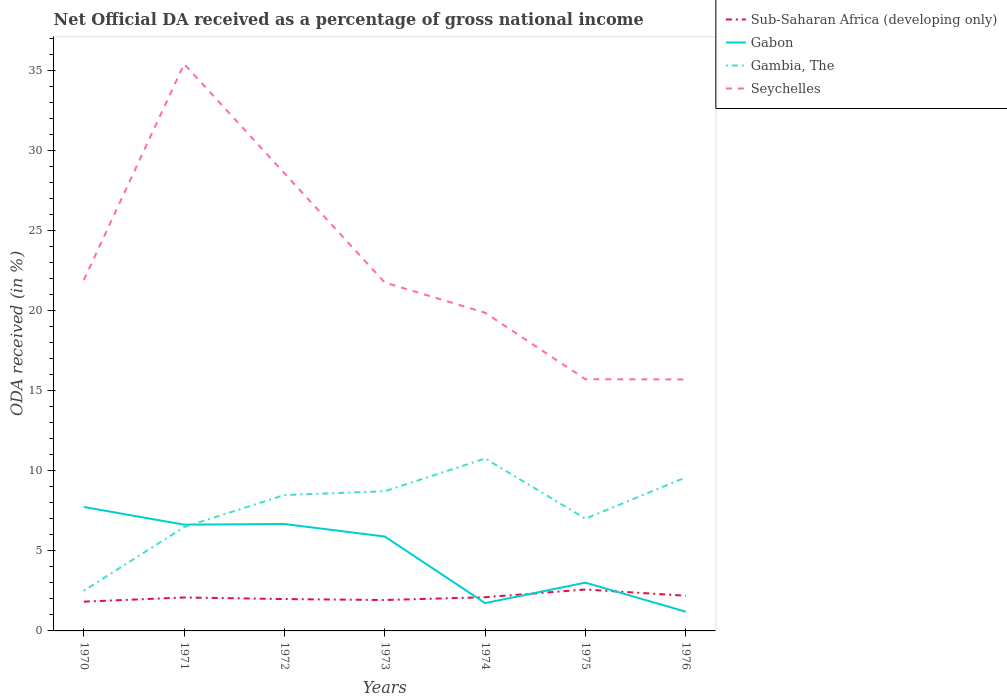How many different coloured lines are there?
Your answer should be very brief. 4. Across all years, what is the maximum net official DA received in Gabon?
Offer a terse response. 1.2. In which year was the net official DA received in Seychelles maximum?
Offer a terse response. 1976. What is the total net official DA received in Gambia, The in the graph?
Give a very brief answer. -0.24. What is the difference between the highest and the second highest net official DA received in Gambia, The?
Provide a short and direct response. 8.26. What is the difference between the highest and the lowest net official DA received in Seychelles?
Offer a terse response. 2. How many lines are there?
Offer a very short reply. 4. How are the legend labels stacked?
Give a very brief answer. Vertical. What is the title of the graph?
Your answer should be very brief. Net Official DA received as a percentage of gross national income. What is the label or title of the Y-axis?
Provide a succinct answer. ODA received (in %). What is the ODA received (in %) of Sub-Saharan Africa (developing only) in 1970?
Your response must be concise. 1.83. What is the ODA received (in %) in Gabon in 1970?
Give a very brief answer. 7.74. What is the ODA received (in %) in Gambia, The in 1970?
Keep it short and to the point. 2.5. What is the ODA received (in %) in Seychelles in 1970?
Keep it short and to the point. 21.9. What is the ODA received (in %) of Sub-Saharan Africa (developing only) in 1971?
Give a very brief answer. 2.09. What is the ODA received (in %) of Gabon in 1971?
Offer a terse response. 6.63. What is the ODA received (in %) of Gambia, The in 1971?
Your answer should be compact. 6.48. What is the ODA received (in %) in Seychelles in 1971?
Ensure brevity in your answer.  35.38. What is the ODA received (in %) in Sub-Saharan Africa (developing only) in 1972?
Provide a short and direct response. 1.99. What is the ODA received (in %) of Gabon in 1972?
Your answer should be compact. 6.67. What is the ODA received (in %) in Gambia, The in 1972?
Give a very brief answer. 8.48. What is the ODA received (in %) of Seychelles in 1972?
Your response must be concise. 28.56. What is the ODA received (in %) of Sub-Saharan Africa (developing only) in 1973?
Your response must be concise. 1.93. What is the ODA received (in %) of Gabon in 1973?
Provide a short and direct response. 5.89. What is the ODA received (in %) of Gambia, The in 1973?
Make the answer very short. 8.72. What is the ODA received (in %) of Seychelles in 1973?
Provide a succinct answer. 21.74. What is the ODA received (in %) of Sub-Saharan Africa (developing only) in 1974?
Offer a terse response. 2.1. What is the ODA received (in %) in Gabon in 1974?
Make the answer very short. 1.74. What is the ODA received (in %) of Gambia, The in 1974?
Keep it short and to the point. 10.76. What is the ODA received (in %) of Seychelles in 1974?
Your answer should be compact. 19.86. What is the ODA received (in %) in Sub-Saharan Africa (developing only) in 1975?
Offer a very short reply. 2.58. What is the ODA received (in %) in Gabon in 1975?
Offer a terse response. 3.01. What is the ODA received (in %) in Gambia, The in 1975?
Offer a very short reply. 7.01. What is the ODA received (in %) of Seychelles in 1975?
Offer a very short reply. 15.71. What is the ODA received (in %) in Sub-Saharan Africa (developing only) in 1976?
Keep it short and to the point. 2.2. What is the ODA received (in %) in Gabon in 1976?
Make the answer very short. 1.2. What is the ODA received (in %) in Gambia, The in 1976?
Keep it short and to the point. 9.58. What is the ODA received (in %) in Seychelles in 1976?
Offer a very short reply. 15.69. Across all years, what is the maximum ODA received (in %) in Sub-Saharan Africa (developing only)?
Ensure brevity in your answer.  2.58. Across all years, what is the maximum ODA received (in %) of Gabon?
Ensure brevity in your answer.  7.74. Across all years, what is the maximum ODA received (in %) in Gambia, The?
Your response must be concise. 10.76. Across all years, what is the maximum ODA received (in %) in Seychelles?
Offer a terse response. 35.38. Across all years, what is the minimum ODA received (in %) of Sub-Saharan Africa (developing only)?
Ensure brevity in your answer.  1.83. Across all years, what is the minimum ODA received (in %) in Gabon?
Offer a terse response. 1.2. Across all years, what is the minimum ODA received (in %) of Gambia, The?
Offer a terse response. 2.5. Across all years, what is the minimum ODA received (in %) of Seychelles?
Your answer should be compact. 15.69. What is the total ODA received (in %) in Sub-Saharan Africa (developing only) in the graph?
Provide a succinct answer. 14.71. What is the total ODA received (in %) in Gabon in the graph?
Keep it short and to the point. 32.88. What is the total ODA received (in %) in Gambia, The in the graph?
Your answer should be compact. 53.53. What is the total ODA received (in %) in Seychelles in the graph?
Your response must be concise. 158.84. What is the difference between the ODA received (in %) in Sub-Saharan Africa (developing only) in 1970 and that in 1971?
Ensure brevity in your answer.  -0.26. What is the difference between the ODA received (in %) in Gabon in 1970 and that in 1971?
Offer a terse response. 1.1. What is the difference between the ODA received (in %) of Gambia, The in 1970 and that in 1971?
Your response must be concise. -3.98. What is the difference between the ODA received (in %) in Seychelles in 1970 and that in 1971?
Your answer should be compact. -13.49. What is the difference between the ODA received (in %) in Sub-Saharan Africa (developing only) in 1970 and that in 1972?
Provide a succinct answer. -0.16. What is the difference between the ODA received (in %) in Gabon in 1970 and that in 1972?
Make the answer very short. 1.06. What is the difference between the ODA received (in %) of Gambia, The in 1970 and that in 1972?
Your answer should be compact. -5.98. What is the difference between the ODA received (in %) in Seychelles in 1970 and that in 1972?
Offer a terse response. -6.66. What is the difference between the ODA received (in %) of Sub-Saharan Africa (developing only) in 1970 and that in 1973?
Offer a very short reply. -0.1. What is the difference between the ODA received (in %) in Gabon in 1970 and that in 1973?
Your answer should be very brief. 1.85. What is the difference between the ODA received (in %) of Gambia, The in 1970 and that in 1973?
Provide a short and direct response. -6.21. What is the difference between the ODA received (in %) of Seychelles in 1970 and that in 1973?
Provide a succinct answer. 0.15. What is the difference between the ODA received (in %) in Sub-Saharan Africa (developing only) in 1970 and that in 1974?
Ensure brevity in your answer.  -0.28. What is the difference between the ODA received (in %) in Gabon in 1970 and that in 1974?
Give a very brief answer. 6. What is the difference between the ODA received (in %) in Gambia, The in 1970 and that in 1974?
Provide a short and direct response. -8.26. What is the difference between the ODA received (in %) of Seychelles in 1970 and that in 1974?
Provide a short and direct response. 2.04. What is the difference between the ODA received (in %) of Sub-Saharan Africa (developing only) in 1970 and that in 1975?
Offer a terse response. -0.76. What is the difference between the ODA received (in %) of Gabon in 1970 and that in 1975?
Provide a succinct answer. 4.72. What is the difference between the ODA received (in %) in Gambia, The in 1970 and that in 1975?
Offer a terse response. -4.5. What is the difference between the ODA received (in %) of Seychelles in 1970 and that in 1975?
Ensure brevity in your answer.  6.19. What is the difference between the ODA received (in %) in Sub-Saharan Africa (developing only) in 1970 and that in 1976?
Your answer should be compact. -0.37. What is the difference between the ODA received (in %) of Gabon in 1970 and that in 1976?
Offer a terse response. 6.54. What is the difference between the ODA received (in %) of Gambia, The in 1970 and that in 1976?
Provide a succinct answer. -7.07. What is the difference between the ODA received (in %) of Seychelles in 1970 and that in 1976?
Your answer should be compact. 6.2. What is the difference between the ODA received (in %) in Sub-Saharan Africa (developing only) in 1971 and that in 1972?
Offer a terse response. 0.1. What is the difference between the ODA received (in %) of Gabon in 1971 and that in 1972?
Keep it short and to the point. -0.04. What is the difference between the ODA received (in %) in Gambia, The in 1971 and that in 1972?
Offer a very short reply. -2. What is the difference between the ODA received (in %) of Seychelles in 1971 and that in 1972?
Give a very brief answer. 6.82. What is the difference between the ODA received (in %) of Sub-Saharan Africa (developing only) in 1971 and that in 1973?
Ensure brevity in your answer.  0.16. What is the difference between the ODA received (in %) in Gabon in 1971 and that in 1973?
Make the answer very short. 0.74. What is the difference between the ODA received (in %) of Gambia, The in 1971 and that in 1973?
Your answer should be compact. -2.23. What is the difference between the ODA received (in %) of Seychelles in 1971 and that in 1973?
Keep it short and to the point. 13.64. What is the difference between the ODA received (in %) of Sub-Saharan Africa (developing only) in 1971 and that in 1974?
Offer a terse response. -0.02. What is the difference between the ODA received (in %) of Gabon in 1971 and that in 1974?
Make the answer very short. 4.89. What is the difference between the ODA received (in %) in Gambia, The in 1971 and that in 1974?
Give a very brief answer. -4.28. What is the difference between the ODA received (in %) of Seychelles in 1971 and that in 1974?
Ensure brevity in your answer.  15.53. What is the difference between the ODA received (in %) in Sub-Saharan Africa (developing only) in 1971 and that in 1975?
Provide a succinct answer. -0.5. What is the difference between the ODA received (in %) in Gabon in 1971 and that in 1975?
Your answer should be very brief. 3.62. What is the difference between the ODA received (in %) in Gambia, The in 1971 and that in 1975?
Make the answer very short. -0.52. What is the difference between the ODA received (in %) of Seychelles in 1971 and that in 1975?
Your response must be concise. 19.68. What is the difference between the ODA received (in %) in Sub-Saharan Africa (developing only) in 1971 and that in 1976?
Give a very brief answer. -0.11. What is the difference between the ODA received (in %) of Gabon in 1971 and that in 1976?
Provide a short and direct response. 5.43. What is the difference between the ODA received (in %) of Gambia, The in 1971 and that in 1976?
Your response must be concise. -3.1. What is the difference between the ODA received (in %) of Seychelles in 1971 and that in 1976?
Give a very brief answer. 19.69. What is the difference between the ODA received (in %) of Sub-Saharan Africa (developing only) in 1972 and that in 1973?
Give a very brief answer. 0.06. What is the difference between the ODA received (in %) in Gabon in 1972 and that in 1973?
Offer a very short reply. 0.78. What is the difference between the ODA received (in %) of Gambia, The in 1972 and that in 1973?
Offer a terse response. -0.23. What is the difference between the ODA received (in %) of Seychelles in 1972 and that in 1973?
Make the answer very short. 6.82. What is the difference between the ODA received (in %) in Sub-Saharan Africa (developing only) in 1972 and that in 1974?
Your answer should be very brief. -0.11. What is the difference between the ODA received (in %) in Gabon in 1972 and that in 1974?
Provide a succinct answer. 4.94. What is the difference between the ODA received (in %) in Gambia, The in 1972 and that in 1974?
Make the answer very short. -2.28. What is the difference between the ODA received (in %) in Seychelles in 1972 and that in 1974?
Your answer should be compact. 8.7. What is the difference between the ODA received (in %) of Sub-Saharan Africa (developing only) in 1972 and that in 1975?
Provide a succinct answer. -0.6. What is the difference between the ODA received (in %) of Gabon in 1972 and that in 1975?
Ensure brevity in your answer.  3.66. What is the difference between the ODA received (in %) in Gambia, The in 1972 and that in 1975?
Provide a short and direct response. 1.48. What is the difference between the ODA received (in %) in Seychelles in 1972 and that in 1975?
Provide a short and direct response. 12.85. What is the difference between the ODA received (in %) of Sub-Saharan Africa (developing only) in 1972 and that in 1976?
Offer a terse response. -0.21. What is the difference between the ODA received (in %) in Gabon in 1972 and that in 1976?
Offer a terse response. 5.47. What is the difference between the ODA received (in %) in Gambia, The in 1972 and that in 1976?
Your response must be concise. -1.1. What is the difference between the ODA received (in %) in Seychelles in 1972 and that in 1976?
Your answer should be compact. 12.86. What is the difference between the ODA received (in %) in Sub-Saharan Africa (developing only) in 1973 and that in 1974?
Your answer should be compact. -0.17. What is the difference between the ODA received (in %) of Gabon in 1973 and that in 1974?
Provide a succinct answer. 4.15. What is the difference between the ODA received (in %) of Gambia, The in 1973 and that in 1974?
Your answer should be very brief. -2.04. What is the difference between the ODA received (in %) of Seychelles in 1973 and that in 1974?
Offer a terse response. 1.89. What is the difference between the ODA received (in %) in Sub-Saharan Africa (developing only) in 1973 and that in 1975?
Provide a short and direct response. -0.66. What is the difference between the ODA received (in %) of Gabon in 1973 and that in 1975?
Give a very brief answer. 2.88. What is the difference between the ODA received (in %) of Gambia, The in 1973 and that in 1975?
Make the answer very short. 1.71. What is the difference between the ODA received (in %) in Seychelles in 1973 and that in 1975?
Make the answer very short. 6.03. What is the difference between the ODA received (in %) in Sub-Saharan Africa (developing only) in 1973 and that in 1976?
Keep it short and to the point. -0.27. What is the difference between the ODA received (in %) in Gabon in 1973 and that in 1976?
Ensure brevity in your answer.  4.69. What is the difference between the ODA received (in %) in Gambia, The in 1973 and that in 1976?
Make the answer very short. -0.86. What is the difference between the ODA received (in %) of Seychelles in 1973 and that in 1976?
Keep it short and to the point. 6.05. What is the difference between the ODA received (in %) in Sub-Saharan Africa (developing only) in 1974 and that in 1975?
Give a very brief answer. -0.48. What is the difference between the ODA received (in %) in Gabon in 1974 and that in 1975?
Ensure brevity in your answer.  -1.28. What is the difference between the ODA received (in %) of Gambia, The in 1974 and that in 1975?
Offer a very short reply. 3.76. What is the difference between the ODA received (in %) in Seychelles in 1974 and that in 1975?
Give a very brief answer. 4.15. What is the difference between the ODA received (in %) of Sub-Saharan Africa (developing only) in 1974 and that in 1976?
Ensure brevity in your answer.  -0.09. What is the difference between the ODA received (in %) in Gabon in 1974 and that in 1976?
Provide a short and direct response. 0.54. What is the difference between the ODA received (in %) of Gambia, The in 1974 and that in 1976?
Offer a terse response. 1.18. What is the difference between the ODA received (in %) in Seychelles in 1974 and that in 1976?
Offer a terse response. 4.16. What is the difference between the ODA received (in %) in Sub-Saharan Africa (developing only) in 1975 and that in 1976?
Keep it short and to the point. 0.39. What is the difference between the ODA received (in %) in Gabon in 1975 and that in 1976?
Ensure brevity in your answer.  1.81. What is the difference between the ODA received (in %) in Gambia, The in 1975 and that in 1976?
Provide a short and direct response. -2.57. What is the difference between the ODA received (in %) of Seychelles in 1975 and that in 1976?
Ensure brevity in your answer.  0.01. What is the difference between the ODA received (in %) in Sub-Saharan Africa (developing only) in 1970 and the ODA received (in %) in Gabon in 1971?
Offer a terse response. -4.8. What is the difference between the ODA received (in %) of Sub-Saharan Africa (developing only) in 1970 and the ODA received (in %) of Gambia, The in 1971?
Give a very brief answer. -4.66. What is the difference between the ODA received (in %) of Sub-Saharan Africa (developing only) in 1970 and the ODA received (in %) of Seychelles in 1971?
Your answer should be compact. -33.56. What is the difference between the ODA received (in %) in Gabon in 1970 and the ODA received (in %) in Gambia, The in 1971?
Make the answer very short. 1.25. What is the difference between the ODA received (in %) in Gabon in 1970 and the ODA received (in %) in Seychelles in 1971?
Ensure brevity in your answer.  -27.65. What is the difference between the ODA received (in %) of Gambia, The in 1970 and the ODA received (in %) of Seychelles in 1971?
Offer a terse response. -32.88. What is the difference between the ODA received (in %) of Sub-Saharan Africa (developing only) in 1970 and the ODA received (in %) of Gabon in 1972?
Your answer should be compact. -4.85. What is the difference between the ODA received (in %) of Sub-Saharan Africa (developing only) in 1970 and the ODA received (in %) of Gambia, The in 1972?
Your response must be concise. -6.65. What is the difference between the ODA received (in %) in Sub-Saharan Africa (developing only) in 1970 and the ODA received (in %) in Seychelles in 1972?
Your answer should be very brief. -26.73. What is the difference between the ODA received (in %) in Gabon in 1970 and the ODA received (in %) in Gambia, The in 1972?
Your answer should be very brief. -0.75. What is the difference between the ODA received (in %) in Gabon in 1970 and the ODA received (in %) in Seychelles in 1972?
Your answer should be very brief. -20.82. What is the difference between the ODA received (in %) in Gambia, The in 1970 and the ODA received (in %) in Seychelles in 1972?
Offer a very short reply. -26.05. What is the difference between the ODA received (in %) in Sub-Saharan Africa (developing only) in 1970 and the ODA received (in %) in Gabon in 1973?
Make the answer very short. -4.06. What is the difference between the ODA received (in %) in Sub-Saharan Africa (developing only) in 1970 and the ODA received (in %) in Gambia, The in 1973?
Provide a short and direct response. -6.89. What is the difference between the ODA received (in %) in Sub-Saharan Africa (developing only) in 1970 and the ODA received (in %) in Seychelles in 1973?
Offer a terse response. -19.92. What is the difference between the ODA received (in %) in Gabon in 1970 and the ODA received (in %) in Gambia, The in 1973?
Your answer should be very brief. -0.98. What is the difference between the ODA received (in %) in Gabon in 1970 and the ODA received (in %) in Seychelles in 1973?
Your answer should be very brief. -14.01. What is the difference between the ODA received (in %) in Gambia, The in 1970 and the ODA received (in %) in Seychelles in 1973?
Give a very brief answer. -19.24. What is the difference between the ODA received (in %) of Sub-Saharan Africa (developing only) in 1970 and the ODA received (in %) of Gabon in 1974?
Provide a succinct answer. 0.09. What is the difference between the ODA received (in %) of Sub-Saharan Africa (developing only) in 1970 and the ODA received (in %) of Gambia, The in 1974?
Make the answer very short. -8.93. What is the difference between the ODA received (in %) of Sub-Saharan Africa (developing only) in 1970 and the ODA received (in %) of Seychelles in 1974?
Keep it short and to the point. -18.03. What is the difference between the ODA received (in %) in Gabon in 1970 and the ODA received (in %) in Gambia, The in 1974?
Your response must be concise. -3.03. What is the difference between the ODA received (in %) of Gabon in 1970 and the ODA received (in %) of Seychelles in 1974?
Offer a terse response. -12.12. What is the difference between the ODA received (in %) of Gambia, The in 1970 and the ODA received (in %) of Seychelles in 1974?
Give a very brief answer. -17.35. What is the difference between the ODA received (in %) in Sub-Saharan Africa (developing only) in 1970 and the ODA received (in %) in Gabon in 1975?
Offer a terse response. -1.19. What is the difference between the ODA received (in %) in Sub-Saharan Africa (developing only) in 1970 and the ODA received (in %) in Gambia, The in 1975?
Make the answer very short. -5.18. What is the difference between the ODA received (in %) in Sub-Saharan Africa (developing only) in 1970 and the ODA received (in %) in Seychelles in 1975?
Give a very brief answer. -13.88. What is the difference between the ODA received (in %) in Gabon in 1970 and the ODA received (in %) in Gambia, The in 1975?
Keep it short and to the point. 0.73. What is the difference between the ODA received (in %) of Gabon in 1970 and the ODA received (in %) of Seychelles in 1975?
Make the answer very short. -7.97. What is the difference between the ODA received (in %) of Gambia, The in 1970 and the ODA received (in %) of Seychelles in 1975?
Your response must be concise. -13.2. What is the difference between the ODA received (in %) of Sub-Saharan Africa (developing only) in 1970 and the ODA received (in %) of Gabon in 1976?
Your response must be concise. 0.63. What is the difference between the ODA received (in %) in Sub-Saharan Africa (developing only) in 1970 and the ODA received (in %) in Gambia, The in 1976?
Offer a very short reply. -7.75. What is the difference between the ODA received (in %) of Sub-Saharan Africa (developing only) in 1970 and the ODA received (in %) of Seychelles in 1976?
Give a very brief answer. -13.87. What is the difference between the ODA received (in %) in Gabon in 1970 and the ODA received (in %) in Gambia, The in 1976?
Offer a very short reply. -1.84. What is the difference between the ODA received (in %) of Gabon in 1970 and the ODA received (in %) of Seychelles in 1976?
Provide a succinct answer. -7.96. What is the difference between the ODA received (in %) in Gambia, The in 1970 and the ODA received (in %) in Seychelles in 1976?
Your answer should be very brief. -13.19. What is the difference between the ODA received (in %) of Sub-Saharan Africa (developing only) in 1971 and the ODA received (in %) of Gabon in 1972?
Ensure brevity in your answer.  -4.59. What is the difference between the ODA received (in %) of Sub-Saharan Africa (developing only) in 1971 and the ODA received (in %) of Gambia, The in 1972?
Provide a succinct answer. -6.39. What is the difference between the ODA received (in %) of Sub-Saharan Africa (developing only) in 1971 and the ODA received (in %) of Seychelles in 1972?
Give a very brief answer. -26.47. What is the difference between the ODA received (in %) in Gabon in 1971 and the ODA received (in %) in Gambia, The in 1972?
Make the answer very short. -1.85. What is the difference between the ODA received (in %) of Gabon in 1971 and the ODA received (in %) of Seychelles in 1972?
Give a very brief answer. -21.93. What is the difference between the ODA received (in %) of Gambia, The in 1971 and the ODA received (in %) of Seychelles in 1972?
Offer a terse response. -22.08. What is the difference between the ODA received (in %) of Sub-Saharan Africa (developing only) in 1971 and the ODA received (in %) of Gabon in 1973?
Offer a very short reply. -3.8. What is the difference between the ODA received (in %) of Sub-Saharan Africa (developing only) in 1971 and the ODA received (in %) of Gambia, The in 1973?
Your response must be concise. -6.63. What is the difference between the ODA received (in %) in Sub-Saharan Africa (developing only) in 1971 and the ODA received (in %) in Seychelles in 1973?
Offer a terse response. -19.66. What is the difference between the ODA received (in %) of Gabon in 1971 and the ODA received (in %) of Gambia, The in 1973?
Offer a terse response. -2.08. What is the difference between the ODA received (in %) of Gabon in 1971 and the ODA received (in %) of Seychelles in 1973?
Your answer should be very brief. -15.11. What is the difference between the ODA received (in %) of Gambia, The in 1971 and the ODA received (in %) of Seychelles in 1973?
Keep it short and to the point. -15.26. What is the difference between the ODA received (in %) in Sub-Saharan Africa (developing only) in 1971 and the ODA received (in %) in Gabon in 1974?
Offer a very short reply. 0.35. What is the difference between the ODA received (in %) of Sub-Saharan Africa (developing only) in 1971 and the ODA received (in %) of Gambia, The in 1974?
Provide a succinct answer. -8.67. What is the difference between the ODA received (in %) of Sub-Saharan Africa (developing only) in 1971 and the ODA received (in %) of Seychelles in 1974?
Provide a short and direct response. -17.77. What is the difference between the ODA received (in %) of Gabon in 1971 and the ODA received (in %) of Gambia, The in 1974?
Keep it short and to the point. -4.13. What is the difference between the ODA received (in %) in Gabon in 1971 and the ODA received (in %) in Seychelles in 1974?
Your answer should be compact. -13.23. What is the difference between the ODA received (in %) in Gambia, The in 1971 and the ODA received (in %) in Seychelles in 1974?
Ensure brevity in your answer.  -13.37. What is the difference between the ODA received (in %) in Sub-Saharan Africa (developing only) in 1971 and the ODA received (in %) in Gabon in 1975?
Offer a very short reply. -0.93. What is the difference between the ODA received (in %) of Sub-Saharan Africa (developing only) in 1971 and the ODA received (in %) of Gambia, The in 1975?
Provide a short and direct response. -4.92. What is the difference between the ODA received (in %) in Sub-Saharan Africa (developing only) in 1971 and the ODA received (in %) in Seychelles in 1975?
Your answer should be very brief. -13.62. What is the difference between the ODA received (in %) of Gabon in 1971 and the ODA received (in %) of Gambia, The in 1975?
Your answer should be compact. -0.37. What is the difference between the ODA received (in %) of Gabon in 1971 and the ODA received (in %) of Seychelles in 1975?
Provide a succinct answer. -9.08. What is the difference between the ODA received (in %) of Gambia, The in 1971 and the ODA received (in %) of Seychelles in 1975?
Your answer should be very brief. -9.23. What is the difference between the ODA received (in %) of Sub-Saharan Africa (developing only) in 1971 and the ODA received (in %) of Gabon in 1976?
Your response must be concise. 0.89. What is the difference between the ODA received (in %) in Sub-Saharan Africa (developing only) in 1971 and the ODA received (in %) in Gambia, The in 1976?
Your answer should be very brief. -7.49. What is the difference between the ODA received (in %) of Sub-Saharan Africa (developing only) in 1971 and the ODA received (in %) of Seychelles in 1976?
Offer a terse response. -13.61. What is the difference between the ODA received (in %) in Gabon in 1971 and the ODA received (in %) in Gambia, The in 1976?
Give a very brief answer. -2.95. What is the difference between the ODA received (in %) of Gabon in 1971 and the ODA received (in %) of Seychelles in 1976?
Your response must be concise. -9.06. What is the difference between the ODA received (in %) of Gambia, The in 1971 and the ODA received (in %) of Seychelles in 1976?
Your answer should be compact. -9.21. What is the difference between the ODA received (in %) of Sub-Saharan Africa (developing only) in 1972 and the ODA received (in %) of Gabon in 1973?
Ensure brevity in your answer.  -3.9. What is the difference between the ODA received (in %) in Sub-Saharan Africa (developing only) in 1972 and the ODA received (in %) in Gambia, The in 1973?
Your answer should be very brief. -6.73. What is the difference between the ODA received (in %) in Sub-Saharan Africa (developing only) in 1972 and the ODA received (in %) in Seychelles in 1973?
Keep it short and to the point. -19.75. What is the difference between the ODA received (in %) in Gabon in 1972 and the ODA received (in %) in Gambia, The in 1973?
Make the answer very short. -2.04. What is the difference between the ODA received (in %) of Gabon in 1972 and the ODA received (in %) of Seychelles in 1973?
Provide a succinct answer. -15.07. What is the difference between the ODA received (in %) in Gambia, The in 1972 and the ODA received (in %) in Seychelles in 1973?
Give a very brief answer. -13.26. What is the difference between the ODA received (in %) in Sub-Saharan Africa (developing only) in 1972 and the ODA received (in %) in Gabon in 1974?
Provide a short and direct response. 0.25. What is the difference between the ODA received (in %) in Sub-Saharan Africa (developing only) in 1972 and the ODA received (in %) in Gambia, The in 1974?
Your response must be concise. -8.77. What is the difference between the ODA received (in %) in Sub-Saharan Africa (developing only) in 1972 and the ODA received (in %) in Seychelles in 1974?
Your answer should be very brief. -17.87. What is the difference between the ODA received (in %) in Gabon in 1972 and the ODA received (in %) in Gambia, The in 1974?
Ensure brevity in your answer.  -4.09. What is the difference between the ODA received (in %) of Gabon in 1972 and the ODA received (in %) of Seychelles in 1974?
Your response must be concise. -13.18. What is the difference between the ODA received (in %) of Gambia, The in 1972 and the ODA received (in %) of Seychelles in 1974?
Give a very brief answer. -11.38. What is the difference between the ODA received (in %) of Sub-Saharan Africa (developing only) in 1972 and the ODA received (in %) of Gabon in 1975?
Keep it short and to the point. -1.02. What is the difference between the ODA received (in %) of Sub-Saharan Africa (developing only) in 1972 and the ODA received (in %) of Gambia, The in 1975?
Offer a very short reply. -5.02. What is the difference between the ODA received (in %) of Sub-Saharan Africa (developing only) in 1972 and the ODA received (in %) of Seychelles in 1975?
Keep it short and to the point. -13.72. What is the difference between the ODA received (in %) in Gabon in 1972 and the ODA received (in %) in Gambia, The in 1975?
Offer a terse response. -0.33. What is the difference between the ODA received (in %) of Gabon in 1972 and the ODA received (in %) of Seychelles in 1975?
Your answer should be compact. -9.03. What is the difference between the ODA received (in %) of Gambia, The in 1972 and the ODA received (in %) of Seychelles in 1975?
Ensure brevity in your answer.  -7.23. What is the difference between the ODA received (in %) of Sub-Saharan Africa (developing only) in 1972 and the ODA received (in %) of Gabon in 1976?
Keep it short and to the point. 0.79. What is the difference between the ODA received (in %) of Sub-Saharan Africa (developing only) in 1972 and the ODA received (in %) of Gambia, The in 1976?
Your response must be concise. -7.59. What is the difference between the ODA received (in %) in Sub-Saharan Africa (developing only) in 1972 and the ODA received (in %) in Seychelles in 1976?
Provide a short and direct response. -13.71. What is the difference between the ODA received (in %) of Gabon in 1972 and the ODA received (in %) of Gambia, The in 1976?
Give a very brief answer. -2.91. What is the difference between the ODA received (in %) of Gabon in 1972 and the ODA received (in %) of Seychelles in 1976?
Offer a very short reply. -9.02. What is the difference between the ODA received (in %) of Gambia, The in 1972 and the ODA received (in %) of Seychelles in 1976?
Your answer should be very brief. -7.21. What is the difference between the ODA received (in %) of Sub-Saharan Africa (developing only) in 1973 and the ODA received (in %) of Gabon in 1974?
Give a very brief answer. 0.19. What is the difference between the ODA received (in %) of Sub-Saharan Africa (developing only) in 1973 and the ODA received (in %) of Gambia, The in 1974?
Offer a terse response. -8.83. What is the difference between the ODA received (in %) of Sub-Saharan Africa (developing only) in 1973 and the ODA received (in %) of Seychelles in 1974?
Your response must be concise. -17.93. What is the difference between the ODA received (in %) in Gabon in 1973 and the ODA received (in %) in Gambia, The in 1974?
Give a very brief answer. -4.87. What is the difference between the ODA received (in %) of Gabon in 1973 and the ODA received (in %) of Seychelles in 1974?
Keep it short and to the point. -13.97. What is the difference between the ODA received (in %) of Gambia, The in 1973 and the ODA received (in %) of Seychelles in 1974?
Your response must be concise. -11.14. What is the difference between the ODA received (in %) of Sub-Saharan Africa (developing only) in 1973 and the ODA received (in %) of Gabon in 1975?
Provide a succinct answer. -1.08. What is the difference between the ODA received (in %) of Sub-Saharan Africa (developing only) in 1973 and the ODA received (in %) of Gambia, The in 1975?
Offer a very short reply. -5.08. What is the difference between the ODA received (in %) of Sub-Saharan Africa (developing only) in 1973 and the ODA received (in %) of Seychelles in 1975?
Make the answer very short. -13.78. What is the difference between the ODA received (in %) in Gabon in 1973 and the ODA received (in %) in Gambia, The in 1975?
Offer a terse response. -1.11. What is the difference between the ODA received (in %) of Gabon in 1973 and the ODA received (in %) of Seychelles in 1975?
Your response must be concise. -9.82. What is the difference between the ODA received (in %) in Gambia, The in 1973 and the ODA received (in %) in Seychelles in 1975?
Your answer should be compact. -6.99. What is the difference between the ODA received (in %) in Sub-Saharan Africa (developing only) in 1973 and the ODA received (in %) in Gabon in 1976?
Provide a succinct answer. 0.73. What is the difference between the ODA received (in %) of Sub-Saharan Africa (developing only) in 1973 and the ODA received (in %) of Gambia, The in 1976?
Give a very brief answer. -7.65. What is the difference between the ODA received (in %) of Sub-Saharan Africa (developing only) in 1973 and the ODA received (in %) of Seychelles in 1976?
Make the answer very short. -13.77. What is the difference between the ODA received (in %) of Gabon in 1973 and the ODA received (in %) of Gambia, The in 1976?
Your answer should be very brief. -3.69. What is the difference between the ODA received (in %) of Gabon in 1973 and the ODA received (in %) of Seychelles in 1976?
Offer a very short reply. -9.8. What is the difference between the ODA received (in %) of Gambia, The in 1973 and the ODA received (in %) of Seychelles in 1976?
Ensure brevity in your answer.  -6.98. What is the difference between the ODA received (in %) of Sub-Saharan Africa (developing only) in 1974 and the ODA received (in %) of Gabon in 1975?
Your answer should be compact. -0.91. What is the difference between the ODA received (in %) of Sub-Saharan Africa (developing only) in 1974 and the ODA received (in %) of Gambia, The in 1975?
Provide a succinct answer. -4.9. What is the difference between the ODA received (in %) in Sub-Saharan Africa (developing only) in 1974 and the ODA received (in %) in Seychelles in 1975?
Make the answer very short. -13.61. What is the difference between the ODA received (in %) in Gabon in 1974 and the ODA received (in %) in Gambia, The in 1975?
Offer a terse response. -5.27. What is the difference between the ODA received (in %) in Gabon in 1974 and the ODA received (in %) in Seychelles in 1975?
Ensure brevity in your answer.  -13.97. What is the difference between the ODA received (in %) of Gambia, The in 1974 and the ODA received (in %) of Seychelles in 1975?
Ensure brevity in your answer.  -4.95. What is the difference between the ODA received (in %) in Sub-Saharan Africa (developing only) in 1974 and the ODA received (in %) in Gabon in 1976?
Your answer should be compact. 0.9. What is the difference between the ODA received (in %) in Sub-Saharan Africa (developing only) in 1974 and the ODA received (in %) in Gambia, The in 1976?
Keep it short and to the point. -7.48. What is the difference between the ODA received (in %) in Sub-Saharan Africa (developing only) in 1974 and the ODA received (in %) in Seychelles in 1976?
Keep it short and to the point. -13.59. What is the difference between the ODA received (in %) of Gabon in 1974 and the ODA received (in %) of Gambia, The in 1976?
Provide a short and direct response. -7.84. What is the difference between the ODA received (in %) in Gabon in 1974 and the ODA received (in %) in Seychelles in 1976?
Provide a succinct answer. -13.96. What is the difference between the ODA received (in %) of Gambia, The in 1974 and the ODA received (in %) of Seychelles in 1976?
Your answer should be compact. -4.93. What is the difference between the ODA received (in %) in Sub-Saharan Africa (developing only) in 1975 and the ODA received (in %) in Gabon in 1976?
Your answer should be compact. 1.38. What is the difference between the ODA received (in %) of Sub-Saharan Africa (developing only) in 1975 and the ODA received (in %) of Gambia, The in 1976?
Offer a terse response. -7. What is the difference between the ODA received (in %) in Sub-Saharan Africa (developing only) in 1975 and the ODA received (in %) in Seychelles in 1976?
Your answer should be very brief. -13.11. What is the difference between the ODA received (in %) of Gabon in 1975 and the ODA received (in %) of Gambia, The in 1976?
Your response must be concise. -6.57. What is the difference between the ODA received (in %) of Gabon in 1975 and the ODA received (in %) of Seychelles in 1976?
Offer a very short reply. -12.68. What is the difference between the ODA received (in %) of Gambia, The in 1975 and the ODA received (in %) of Seychelles in 1976?
Offer a terse response. -8.69. What is the average ODA received (in %) of Sub-Saharan Africa (developing only) per year?
Your answer should be very brief. 2.1. What is the average ODA received (in %) in Gabon per year?
Give a very brief answer. 4.7. What is the average ODA received (in %) of Gambia, The per year?
Keep it short and to the point. 7.65. What is the average ODA received (in %) of Seychelles per year?
Your answer should be compact. 22.69. In the year 1970, what is the difference between the ODA received (in %) in Sub-Saharan Africa (developing only) and ODA received (in %) in Gabon?
Your answer should be compact. -5.91. In the year 1970, what is the difference between the ODA received (in %) in Sub-Saharan Africa (developing only) and ODA received (in %) in Gambia, The?
Your answer should be compact. -0.68. In the year 1970, what is the difference between the ODA received (in %) in Sub-Saharan Africa (developing only) and ODA received (in %) in Seychelles?
Your response must be concise. -20.07. In the year 1970, what is the difference between the ODA received (in %) in Gabon and ODA received (in %) in Gambia, The?
Offer a very short reply. 5.23. In the year 1970, what is the difference between the ODA received (in %) in Gabon and ODA received (in %) in Seychelles?
Give a very brief answer. -14.16. In the year 1970, what is the difference between the ODA received (in %) of Gambia, The and ODA received (in %) of Seychelles?
Offer a terse response. -19.39. In the year 1971, what is the difference between the ODA received (in %) in Sub-Saharan Africa (developing only) and ODA received (in %) in Gabon?
Your answer should be very brief. -4.54. In the year 1971, what is the difference between the ODA received (in %) in Sub-Saharan Africa (developing only) and ODA received (in %) in Gambia, The?
Offer a very short reply. -4.4. In the year 1971, what is the difference between the ODA received (in %) of Sub-Saharan Africa (developing only) and ODA received (in %) of Seychelles?
Provide a short and direct response. -33.3. In the year 1971, what is the difference between the ODA received (in %) in Gabon and ODA received (in %) in Gambia, The?
Your answer should be compact. 0.15. In the year 1971, what is the difference between the ODA received (in %) of Gabon and ODA received (in %) of Seychelles?
Your answer should be compact. -28.75. In the year 1971, what is the difference between the ODA received (in %) in Gambia, The and ODA received (in %) in Seychelles?
Keep it short and to the point. -28.9. In the year 1972, what is the difference between the ODA received (in %) of Sub-Saharan Africa (developing only) and ODA received (in %) of Gabon?
Offer a very short reply. -4.68. In the year 1972, what is the difference between the ODA received (in %) of Sub-Saharan Africa (developing only) and ODA received (in %) of Gambia, The?
Give a very brief answer. -6.49. In the year 1972, what is the difference between the ODA received (in %) in Sub-Saharan Africa (developing only) and ODA received (in %) in Seychelles?
Your answer should be very brief. -26.57. In the year 1972, what is the difference between the ODA received (in %) of Gabon and ODA received (in %) of Gambia, The?
Provide a short and direct response. -1.81. In the year 1972, what is the difference between the ODA received (in %) of Gabon and ODA received (in %) of Seychelles?
Keep it short and to the point. -21.89. In the year 1972, what is the difference between the ODA received (in %) in Gambia, The and ODA received (in %) in Seychelles?
Provide a short and direct response. -20.08. In the year 1973, what is the difference between the ODA received (in %) of Sub-Saharan Africa (developing only) and ODA received (in %) of Gabon?
Ensure brevity in your answer.  -3.96. In the year 1973, what is the difference between the ODA received (in %) in Sub-Saharan Africa (developing only) and ODA received (in %) in Gambia, The?
Your response must be concise. -6.79. In the year 1973, what is the difference between the ODA received (in %) in Sub-Saharan Africa (developing only) and ODA received (in %) in Seychelles?
Offer a terse response. -19.81. In the year 1973, what is the difference between the ODA received (in %) of Gabon and ODA received (in %) of Gambia, The?
Offer a terse response. -2.83. In the year 1973, what is the difference between the ODA received (in %) of Gabon and ODA received (in %) of Seychelles?
Your response must be concise. -15.85. In the year 1973, what is the difference between the ODA received (in %) of Gambia, The and ODA received (in %) of Seychelles?
Keep it short and to the point. -13.03. In the year 1974, what is the difference between the ODA received (in %) of Sub-Saharan Africa (developing only) and ODA received (in %) of Gabon?
Give a very brief answer. 0.37. In the year 1974, what is the difference between the ODA received (in %) in Sub-Saharan Africa (developing only) and ODA received (in %) in Gambia, The?
Offer a very short reply. -8.66. In the year 1974, what is the difference between the ODA received (in %) of Sub-Saharan Africa (developing only) and ODA received (in %) of Seychelles?
Offer a very short reply. -17.75. In the year 1974, what is the difference between the ODA received (in %) in Gabon and ODA received (in %) in Gambia, The?
Provide a succinct answer. -9.02. In the year 1974, what is the difference between the ODA received (in %) in Gabon and ODA received (in %) in Seychelles?
Provide a short and direct response. -18.12. In the year 1974, what is the difference between the ODA received (in %) of Gambia, The and ODA received (in %) of Seychelles?
Keep it short and to the point. -9.1. In the year 1975, what is the difference between the ODA received (in %) in Sub-Saharan Africa (developing only) and ODA received (in %) in Gabon?
Offer a very short reply. -0.43. In the year 1975, what is the difference between the ODA received (in %) of Sub-Saharan Africa (developing only) and ODA received (in %) of Gambia, The?
Provide a short and direct response. -4.42. In the year 1975, what is the difference between the ODA received (in %) of Sub-Saharan Africa (developing only) and ODA received (in %) of Seychelles?
Make the answer very short. -13.12. In the year 1975, what is the difference between the ODA received (in %) of Gabon and ODA received (in %) of Gambia, The?
Your answer should be very brief. -3.99. In the year 1975, what is the difference between the ODA received (in %) of Gabon and ODA received (in %) of Seychelles?
Offer a very short reply. -12.69. In the year 1975, what is the difference between the ODA received (in %) of Gambia, The and ODA received (in %) of Seychelles?
Your answer should be compact. -8.7. In the year 1976, what is the difference between the ODA received (in %) of Sub-Saharan Africa (developing only) and ODA received (in %) of Gabon?
Provide a short and direct response. 1. In the year 1976, what is the difference between the ODA received (in %) in Sub-Saharan Africa (developing only) and ODA received (in %) in Gambia, The?
Keep it short and to the point. -7.38. In the year 1976, what is the difference between the ODA received (in %) of Sub-Saharan Africa (developing only) and ODA received (in %) of Seychelles?
Your answer should be compact. -13.5. In the year 1976, what is the difference between the ODA received (in %) in Gabon and ODA received (in %) in Gambia, The?
Offer a terse response. -8.38. In the year 1976, what is the difference between the ODA received (in %) in Gabon and ODA received (in %) in Seychelles?
Offer a terse response. -14.5. In the year 1976, what is the difference between the ODA received (in %) in Gambia, The and ODA received (in %) in Seychelles?
Your answer should be compact. -6.12. What is the ratio of the ODA received (in %) of Sub-Saharan Africa (developing only) in 1970 to that in 1971?
Offer a terse response. 0.88. What is the ratio of the ODA received (in %) in Gabon in 1970 to that in 1971?
Offer a terse response. 1.17. What is the ratio of the ODA received (in %) in Gambia, The in 1970 to that in 1971?
Make the answer very short. 0.39. What is the ratio of the ODA received (in %) of Seychelles in 1970 to that in 1971?
Offer a very short reply. 0.62. What is the ratio of the ODA received (in %) of Sub-Saharan Africa (developing only) in 1970 to that in 1972?
Offer a very short reply. 0.92. What is the ratio of the ODA received (in %) in Gabon in 1970 to that in 1972?
Provide a succinct answer. 1.16. What is the ratio of the ODA received (in %) in Gambia, The in 1970 to that in 1972?
Give a very brief answer. 0.3. What is the ratio of the ODA received (in %) in Seychelles in 1970 to that in 1972?
Your response must be concise. 0.77. What is the ratio of the ODA received (in %) in Sub-Saharan Africa (developing only) in 1970 to that in 1973?
Give a very brief answer. 0.95. What is the ratio of the ODA received (in %) in Gabon in 1970 to that in 1973?
Provide a short and direct response. 1.31. What is the ratio of the ODA received (in %) of Gambia, The in 1970 to that in 1973?
Your answer should be compact. 0.29. What is the ratio of the ODA received (in %) of Seychelles in 1970 to that in 1973?
Give a very brief answer. 1.01. What is the ratio of the ODA received (in %) of Sub-Saharan Africa (developing only) in 1970 to that in 1974?
Make the answer very short. 0.87. What is the ratio of the ODA received (in %) of Gabon in 1970 to that in 1974?
Make the answer very short. 4.46. What is the ratio of the ODA received (in %) of Gambia, The in 1970 to that in 1974?
Offer a very short reply. 0.23. What is the ratio of the ODA received (in %) of Seychelles in 1970 to that in 1974?
Provide a short and direct response. 1.1. What is the ratio of the ODA received (in %) of Sub-Saharan Africa (developing only) in 1970 to that in 1975?
Your response must be concise. 0.71. What is the ratio of the ODA received (in %) in Gabon in 1970 to that in 1975?
Offer a terse response. 2.57. What is the ratio of the ODA received (in %) of Gambia, The in 1970 to that in 1975?
Offer a terse response. 0.36. What is the ratio of the ODA received (in %) of Seychelles in 1970 to that in 1975?
Your answer should be very brief. 1.39. What is the ratio of the ODA received (in %) in Sub-Saharan Africa (developing only) in 1970 to that in 1976?
Your response must be concise. 0.83. What is the ratio of the ODA received (in %) in Gabon in 1970 to that in 1976?
Your response must be concise. 6.45. What is the ratio of the ODA received (in %) in Gambia, The in 1970 to that in 1976?
Offer a terse response. 0.26. What is the ratio of the ODA received (in %) in Seychelles in 1970 to that in 1976?
Give a very brief answer. 1.4. What is the ratio of the ODA received (in %) in Sub-Saharan Africa (developing only) in 1971 to that in 1972?
Provide a short and direct response. 1.05. What is the ratio of the ODA received (in %) in Gambia, The in 1971 to that in 1972?
Keep it short and to the point. 0.76. What is the ratio of the ODA received (in %) of Seychelles in 1971 to that in 1972?
Provide a succinct answer. 1.24. What is the ratio of the ODA received (in %) of Sub-Saharan Africa (developing only) in 1971 to that in 1973?
Keep it short and to the point. 1.08. What is the ratio of the ODA received (in %) of Gabon in 1971 to that in 1973?
Your answer should be compact. 1.13. What is the ratio of the ODA received (in %) of Gambia, The in 1971 to that in 1973?
Your answer should be very brief. 0.74. What is the ratio of the ODA received (in %) of Seychelles in 1971 to that in 1973?
Your answer should be compact. 1.63. What is the ratio of the ODA received (in %) of Sub-Saharan Africa (developing only) in 1971 to that in 1974?
Ensure brevity in your answer.  0.99. What is the ratio of the ODA received (in %) of Gabon in 1971 to that in 1974?
Offer a terse response. 3.82. What is the ratio of the ODA received (in %) of Gambia, The in 1971 to that in 1974?
Your response must be concise. 0.6. What is the ratio of the ODA received (in %) of Seychelles in 1971 to that in 1974?
Make the answer very short. 1.78. What is the ratio of the ODA received (in %) in Sub-Saharan Africa (developing only) in 1971 to that in 1975?
Your answer should be very brief. 0.81. What is the ratio of the ODA received (in %) of Gabon in 1971 to that in 1975?
Your answer should be very brief. 2.2. What is the ratio of the ODA received (in %) in Gambia, The in 1971 to that in 1975?
Make the answer very short. 0.93. What is the ratio of the ODA received (in %) in Seychelles in 1971 to that in 1975?
Offer a very short reply. 2.25. What is the ratio of the ODA received (in %) in Sub-Saharan Africa (developing only) in 1971 to that in 1976?
Offer a very short reply. 0.95. What is the ratio of the ODA received (in %) in Gabon in 1971 to that in 1976?
Keep it short and to the point. 5.53. What is the ratio of the ODA received (in %) of Gambia, The in 1971 to that in 1976?
Offer a terse response. 0.68. What is the ratio of the ODA received (in %) of Seychelles in 1971 to that in 1976?
Ensure brevity in your answer.  2.25. What is the ratio of the ODA received (in %) in Sub-Saharan Africa (developing only) in 1972 to that in 1973?
Keep it short and to the point. 1.03. What is the ratio of the ODA received (in %) of Gabon in 1972 to that in 1973?
Ensure brevity in your answer.  1.13. What is the ratio of the ODA received (in %) of Gambia, The in 1972 to that in 1973?
Make the answer very short. 0.97. What is the ratio of the ODA received (in %) of Seychelles in 1972 to that in 1973?
Your response must be concise. 1.31. What is the ratio of the ODA received (in %) of Sub-Saharan Africa (developing only) in 1972 to that in 1974?
Your answer should be compact. 0.95. What is the ratio of the ODA received (in %) in Gabon in 1972 to that in 1974?
Offer a very short reply. 3.84. What is the ratio of the ODA received (in %) in Gambia, The in 1972 to that in 1974?
Provide a succinct answer. 0.79. What is the ratio of the ODA received (in %) in Seychelles in 1972 to that in 1974?
Keep it short and to the point. 1.44. What is the ratio of the ODA received (in %) of Sub-Saharan Africa (developing only) in 1972 to that in 1975?
Ensure brevity in your answer.  0.77. What is the ratio of the ODA received (in %) of Gabon in 1972 to that in 1975?
Make the answer very short. 2.21. What is the ratio of the ODA received (in %) of Gambia, The in 1972 to that in 1975?
Give a very brief answer. 1.21. What is the ratio of the ODA received (in %) in Seychelles in 1972 to that in 1975?
Offer a very short reply. 1.82. What is the ratio of the ODA received (in %) in Sub-Saharan Africa (developing only) in 1972 to that in 1976?
Keep it short and to the point. 0.91. What is the ratio of the ODA received (in %) of Gabon in 1972 to that in 1976?
Your answer should be very brief. 5.56. What is the ratio of the ODA received (in %) of Gambia, The in 1972 to that in 1976?
Keep it short and to the point. 0.89. What is the ratio of the ODA received (in %) in Seychelles in 1972 to that in 1976?
Provide a short and direct response. 1.82. What is the ratio of the ODA received (in %) in Sub-Saharan Africa (developing only) in 1973 to that in 1974?
Your answer should be compact. 0.92. What is the ratio of the ODA received (in %) in Gabon in 1973 to that in 1974?
Offer a terse response. 3.39. What is the ratio of the ODA received (in %) of Gambia, The in 1973 to that in 1974?
Give a very brief answer. 0.81. What is the ratio of the ODA received (in %) in Seychelles in 1973 to that in 1974?
Keep it short and to the point. 1.09. What is the ratio of the ODA received (in %) of Sub-Saharan Africa (developing only) in 1973 to that in 1975?
Keep it short and to the point. 0.75. What is the ratio of the ODA received (in %) of Gabon in 1973 to that in 1975?
Keep it short and to the point. 1.95. What is the ratio of the ODA received (in %) of Gambia, The in 1973 to that in 1975?
Offer a terse response. 1.24. What is the ratio of the ODA received (in %) in Seychelles in 1973 to that in 1975?
Give a very brief answer. 1.38. What is the ratio of the ODA received (in %) of Sub-Saharan Africa (developing only) in 1973 to that in 1976?
Provide a short and direct response. 0.88. What is the ratio of the ODA received (in %) of Gabon in 1973 to that in 1976?
Offer a terse response. 4.91. What is the ratio of the ODA received (in %) of Gambia, The in 1973 to that in 1976?
Your answer should be very brief. 0.91. What is the ratio of the ODA received (in %) of Seychelles in 1973 to that in 1976?
Offer a terse response. 1.39. What is the ratio of the ODA received (in %) in Sub-Saharan Africa (developing only) in 1974 to that in 1975?
Your answer should be very brief. 0.81. What is the ratio of the ODA received (in %) of Gabon in 1974 to that in 1975?
Offer a very short reply. 0.58. What is the ratio of the ODA received (in %) in Gambia, The in 1974 to that in 1975?
Make the answer very short. 1.54. What is the ratio of the ODA received (in %) in Seychelles in 1974 to that in 1975?
Give a very brief answer. 1.26. What is the ratio of the ODA received (in %) in Sub-Saharan Africa (developing only) in 1974 to that in 1976?
Give a very brief answer. 0.96. What is the ratio of the ODA received (in %) in Gabon in 1974 to that in 1976?
Your answer should be compact. 1.45. What is the ratio of the ODA received (in %) in Gambia, The in 1974 to that in 1976?
Your answer should be very brief. 1.12. What is the ratio of the ODA received (in %) in Seychelles in 1974 to that in 1976?
Provide a short and direct response. 1.27. What is the ratio of the ODA received (in %) of Sub-Saharan Africa (developing only) in 1975 to that in 1976?
Your answer should be very brief. 1.18. What is the ratio of the ODA received (in %) of Gabon in 1975 to that in 1976?
Provide a short and direct response. 2.51. What is the ratio of the ODA received (in %) of Gambia, The in 1975 to that in 1976?
Make the answer very short. 0.73. What is the difference between the highest and the second highest ODA received (in %) in Sub-Saharan Africa (developing only)?
Your response must be concise. 0.39. What is the difference between the highest and the second highest ODA received (in %) of Gabon?
Give a very brief answer. 1.06. What is the difference between the highest and the second highest ODA received (in %) of Gambia, The?
Offer a terse response. 1.18. What is the difference between the highest and the second highest ODA received (in %) of Seychelles?
Offer a terse response. 6.82. What is the difference between the highest and the lowest ODA received (in %) of Sub-Saharan Africa (developing only)?
Keep it short and to the point. 0.76. What is the difference between the highest and the lowest ODA received (in %) of Gabon?
Provide a short and direct response. 6.54. What is the difference between the highest and the lowest ODA received (in %) of Gambia, The?
Your response must be concise. 8.26. What is the difference between the highest and the lowest ODA received (in %) in Seychelles?
Your answer should be compact. 19.69. 